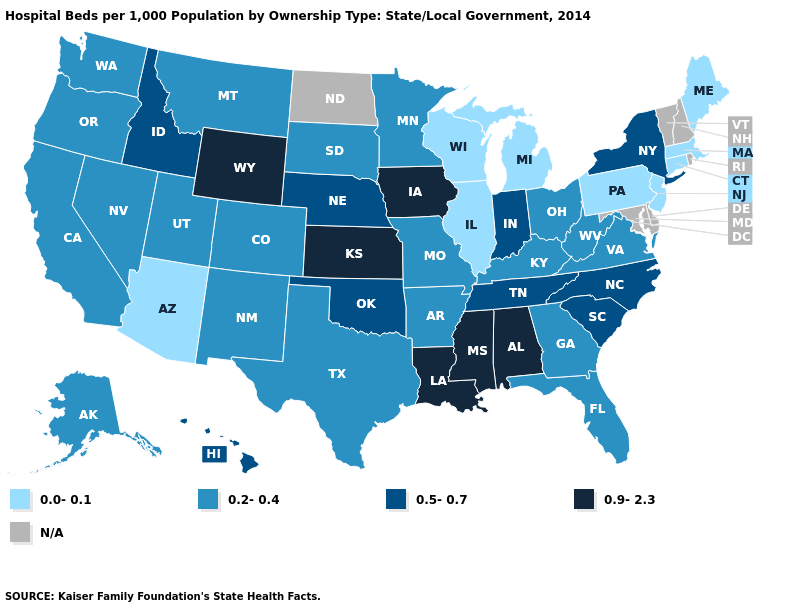How many symbols are there in the legend?
Short answer required. 5. What is the value of Arkansas?
Answer briefly. 0.2-0.4. What is the value of Minnesota?
Be succinct. 0.2-0.4. What is the value of California?
Answer briefly. 0.2-0.4. What is the highest value in states that border New Hampshire?
Answer briefly. 0.0-0.1. What is the lowest value in the Northeast?
Quick response, please. 0.0-0.1. Which states have the lowest value in the West?
Keep it brief. Arizona. Is the legend a continuous bar?
Answer briefly. No. Is the legend a continuous bar?
Quick response, please. No. What is the value of Idaho?
Quick response, please. 0.5-0.7. Among the states that border Virginia , does Tennessee have the lowest value?
Give a very brief answer. No. Name the states that have a value in the range N/A?
Answer briefly. Delaware, Maryland, New Hampshire, North Dakota, Rhode Island, Vermont. What is the value of Oklahoma?
Write a very short answer. 0.5-0.7. What is the highest value in the USA?
Concise answer only. 0.9-2.3. 